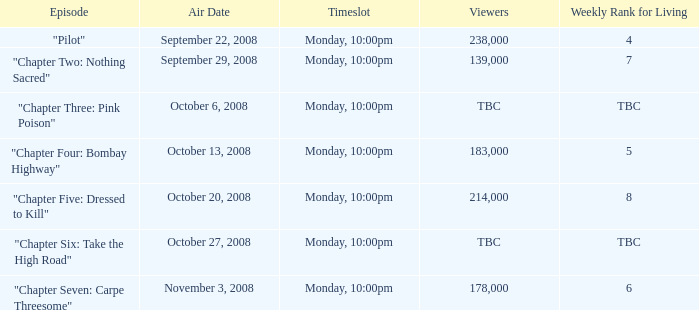For the episode with a weekly living rank of 4, how many viewers were there? 238000.0. 